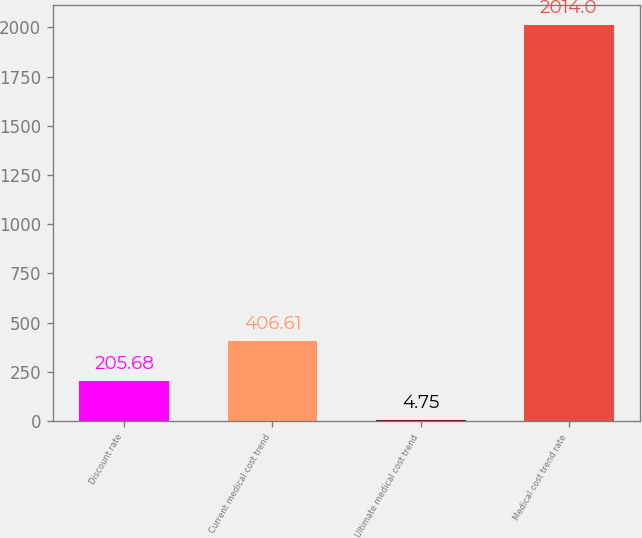Convert chart to OTSL. <chart><loc_0><loc_0><loc_500><loc_500><bar_chart><fcel>Discount rate<fcel>Current medical cost trend<fcel>Ultimate medical cost trend<fcel>Medical cost trend rate<nl><fcel>205.68<fcel>406.61<fcel>4.75<fcel>2014<nl></chart> 